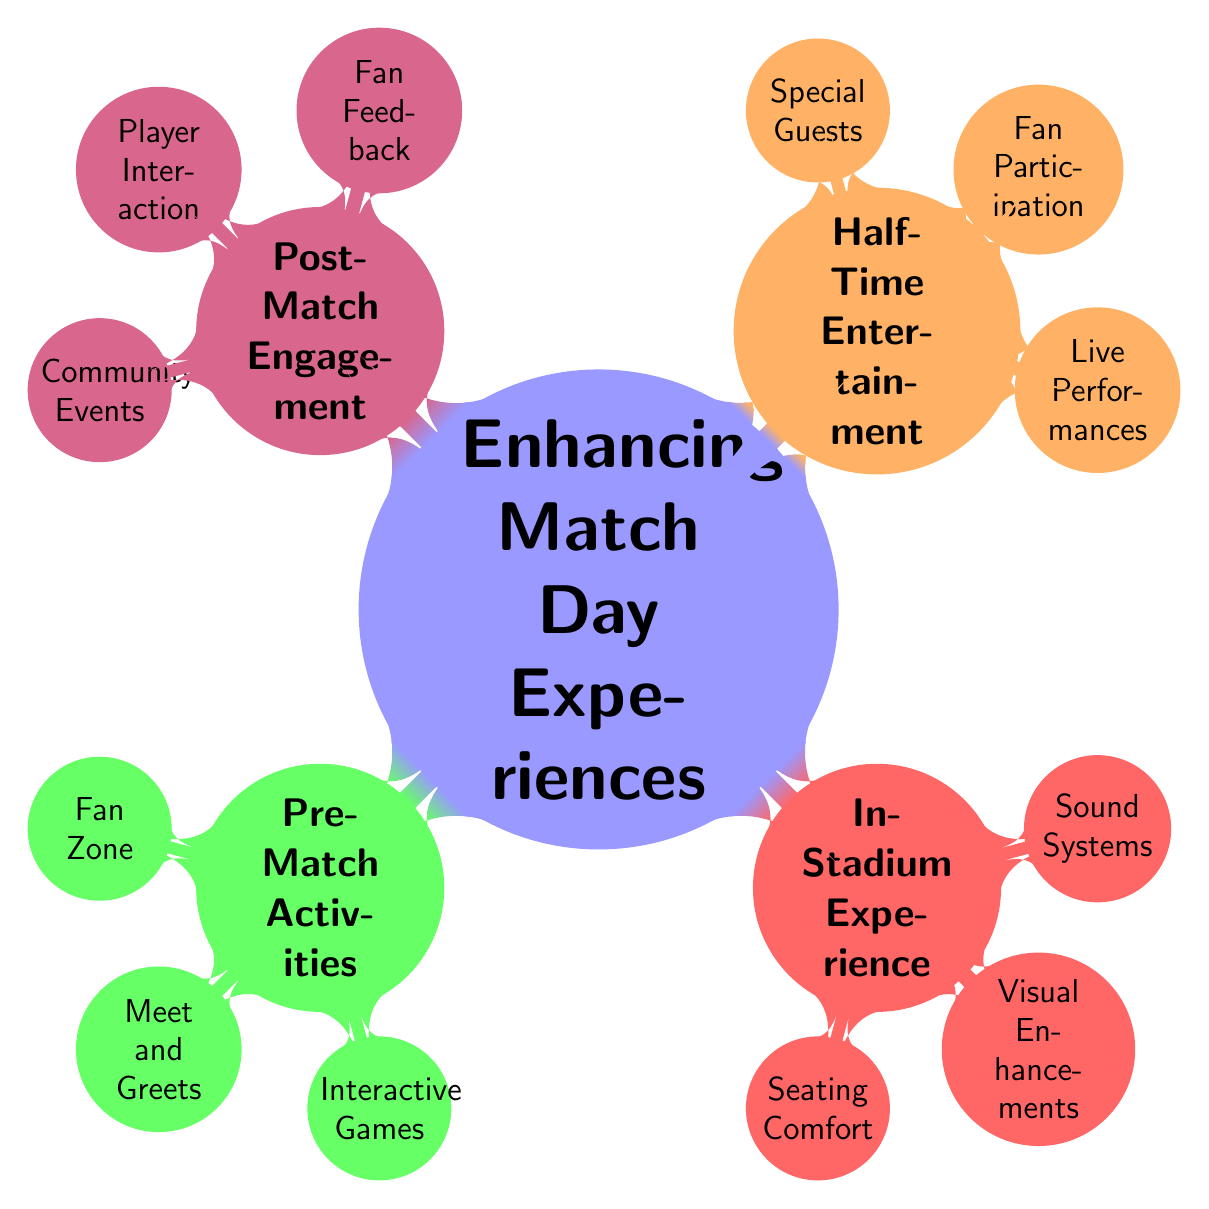What are the main categories for enhancing match day experiences? The diagram consists of four main categories that are branching from the central idea. They are "Pre-Match Activities", "In-Stadium Experience", "Half-Time Entertainment", and "Post-Match Engagement".
Answer: Pre-Match Activities, In-Stadium Experience, Half-Time Entertainment, Post-Match Engagement How many subcategories are there under “In-Stadium Experience”? Under "In-Stadium Experience", there are three subcategories: "Seating Comfort", "Visual Enhancements", and "Sound Systems". This can be counted directly from the branches stemming from this node.
Answer: 3 What type of entertainment is provided during half-time? The subcategories listed under "Half-Time Entertainment" include "Live Performances", "Fan Participation", and "Special Guests".
Answer: Live Performances, Fan Participation, Special Guests What type of feedback is gathered in "Post-Match Engagement"? In "Post-Match Engagement", the methods for feedback are categorized as "Fan Feedback", which includes "Surveys" and "Focus Groups".
Answer: Surveys, Focus Groups Which pre-match activity involves player interactions? The "Meet and Greets" subcategory under "Pre-Match Activities" includes player interactions such as "Player Autographs" and "Photo Opportunities".
Answer: Meet and Greets Which category has upgrades related to comfort? The "In-Stadium Experience" category has "Seating Comfort" as a subcategory focusing on upgrades, explicitly mentioned as "Upgraded Seats" and "Family Sections".
Answer: Seating Comfort What kind of activities are included in the "Fan Zone"? Under "Fan Zone", the activities mentioned are "Live Music", "Food Trucks", and "Merchandise Stalls", which are directly listed as offerings in this pre-match area.
Answer: Live Music, Food Trucks, Merchandise Stalls How do "Player Interaction" activities fit into the overall match day experience? "Player Interaction" is part of "Post-Match Engagement", highlighting the relationship by showing that it is a way to engage fans after the match through activities like "Post-Match Interviews" and "Autograph Sessions".
Answer: Post-Match Engagement How many total areas target supporter experiences specifically? The diagram presents a total of four main areas that are outlined to enhance supporter experiences during the match day.
Answer: 4 